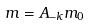Convert formula to latex. <formula><loc_0><loc_0><loc_500><loc_500>m = A _ { - k } m _ { 0 }</formula> 